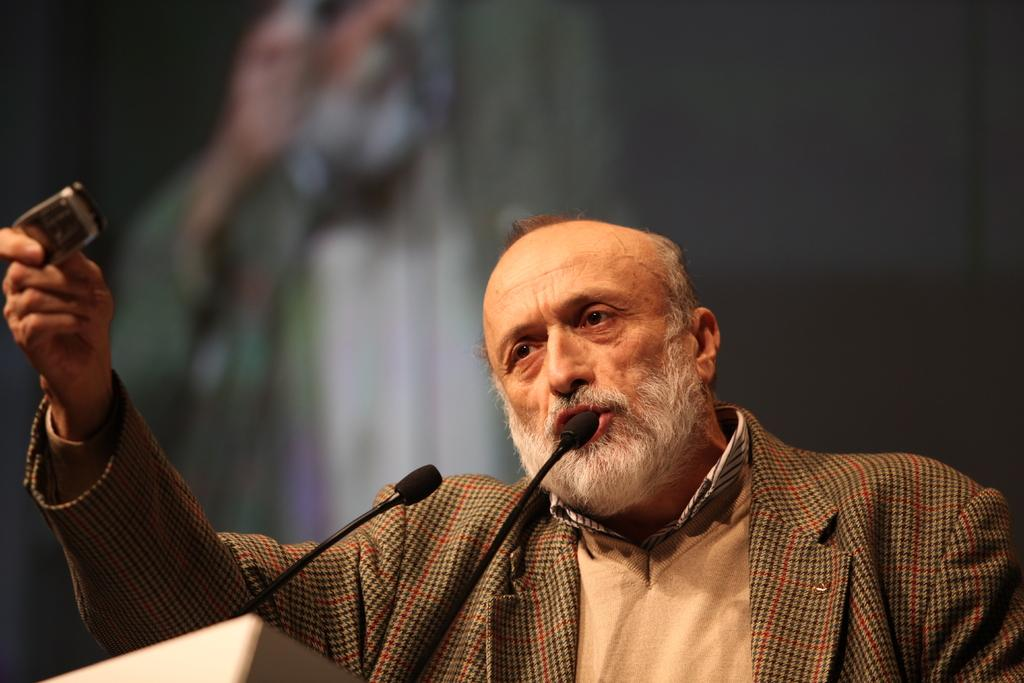What is the main subject of the image? There is a person in the image. What is the person doing with their hands? The person is holding an object. Can you describe what the person is doing with their mouth? The person is talking into a microphone. What type of apparel is the person wearing in the image? The provided facts do not mention any specific apparel that the person is wearing. 